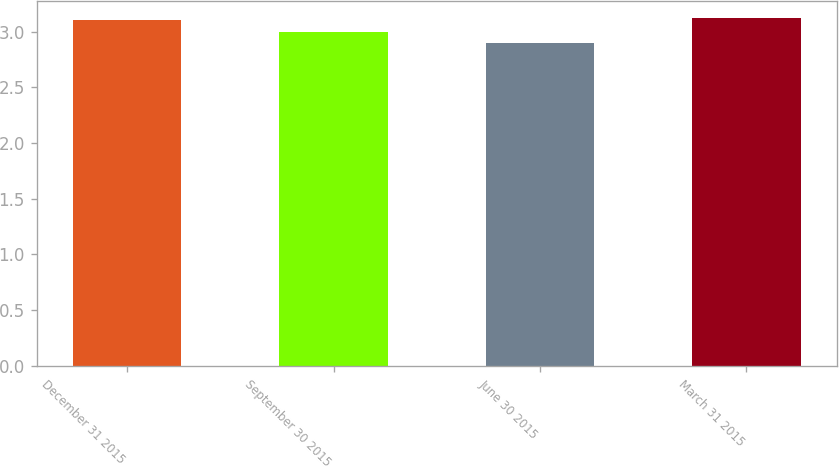Convert chart to OTSL. <chart><loc_0><loc_0><loc_500><loc_500><bar_chart><fcel>December 31 2015<fcel>September 30 2015<fcel>June 30 2015<fcel>March 31 2015<nl><fcel>3.1<fcel>3<fcel>2.9<fcel>3.12<nl></chart> 